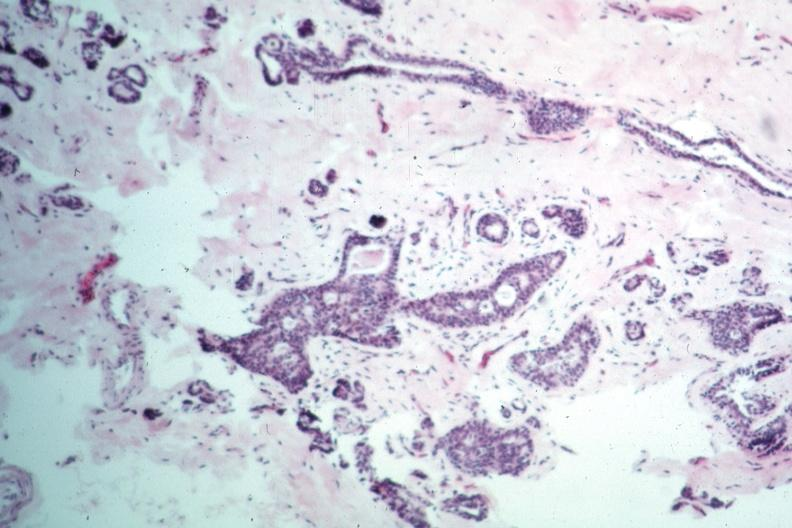s sacrococcygeal teratoma present?
Answer the question using a single word or phrase. No 